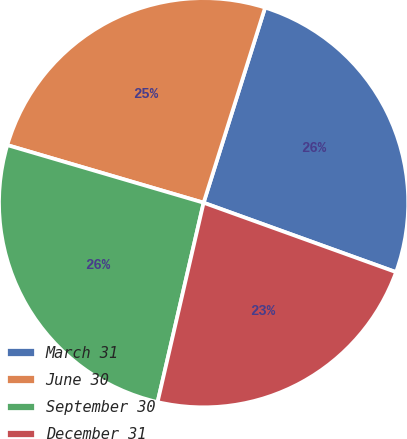Convert chart. <chart><loc_0><loc_0><loc_500><loc_500><pie_chart><fcel>March 31<fcel>June 30<fcel>September 30<fcel>December 31<nl><fcel>25.65%<fcel>25.31%<fcel>25.93%<fcel>23.1%<nl></chart> 